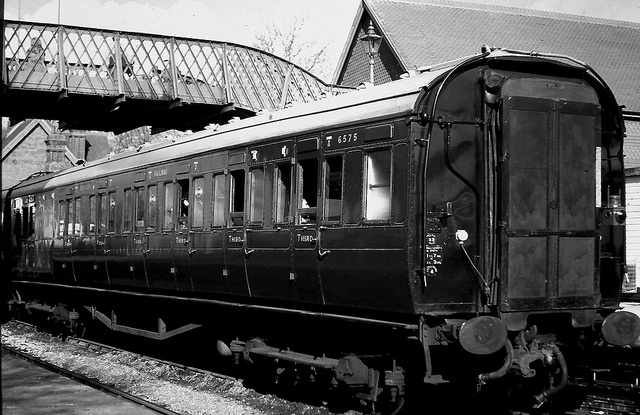Describe the objects in this image and their specific colors. I can see train in black, gray, lightgray, and darkgray tones, people in black, darkgray, gray, and lightgray tones, and people in black, darkgray, gray, and lightgray tones in this image. 